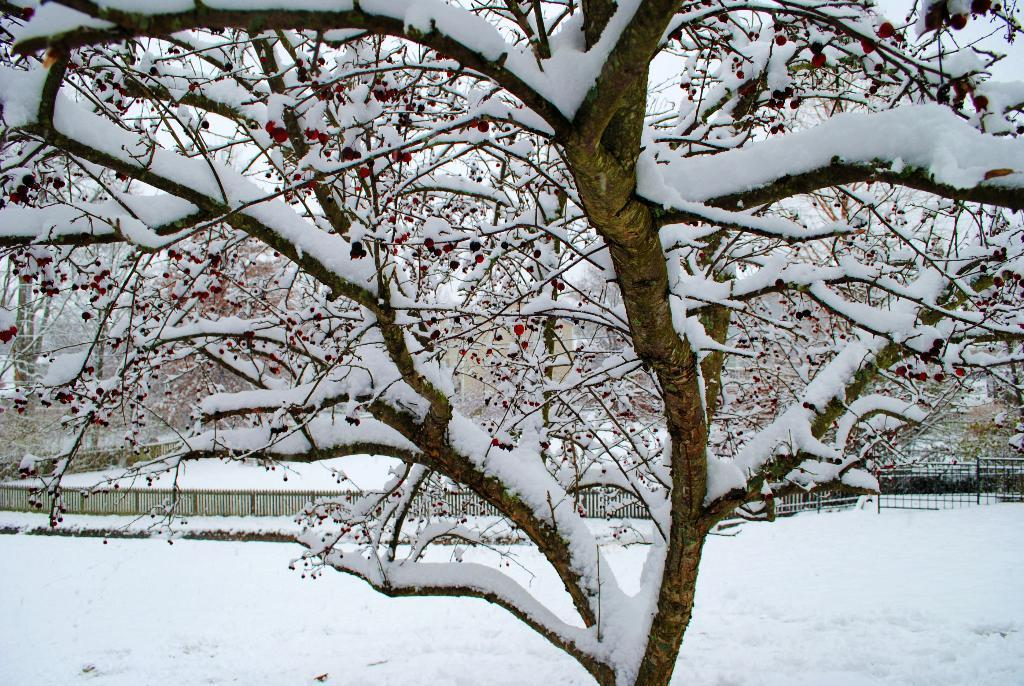What is located in the middle of the image? There are trees in the middle of the image. What is covering the trees in the image? Snow is present on the trees. What can be seen behind the trees in the image? There is fencing visible behind the trees. What is present at the bottom of the image? Snow is present at the bottom of the image. Where is the flame located in the image? There is no flame present in the image. What type of lead can be seen in the image? There is no lead present in the image. 